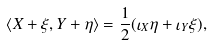Convert formula to latex. <formula><loc_0><loc_0><loc_500><loc_500>\langle X + \xi , Y + \eta \rangle = \frac { 1 } { 2 } ( \iota _ { X } \eta + \iota _ { Y } \xi ) ,</formula> 